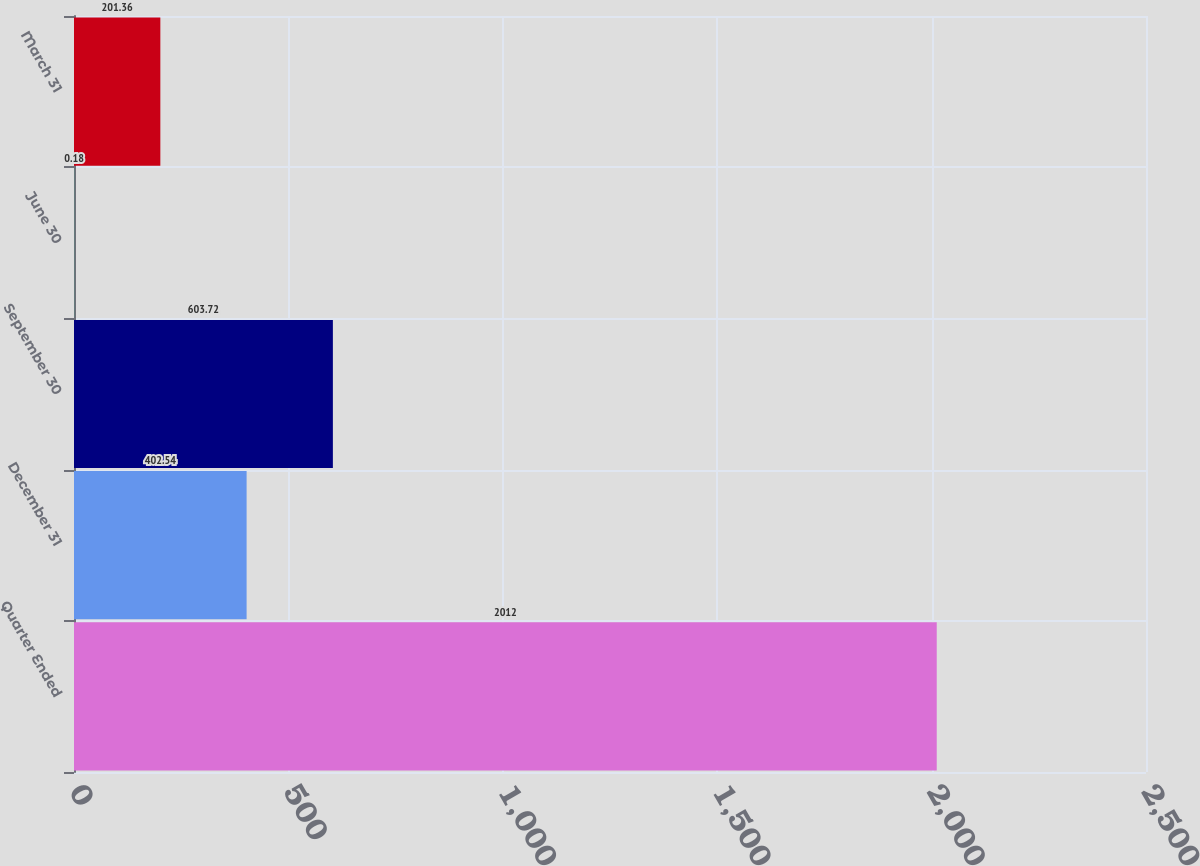Convert chart. <chart><loc_0><loc_0><loc_500><loc_500><bar_chart><fcel>Quarter Ended<fcel>December 31<fcel>September 30<fcel>June 30<fcel>March 31<nl><fcel>2012<fcel>402.54<fcel>603.72<fcel>0.18<fcel>201.36<nl></chart> 